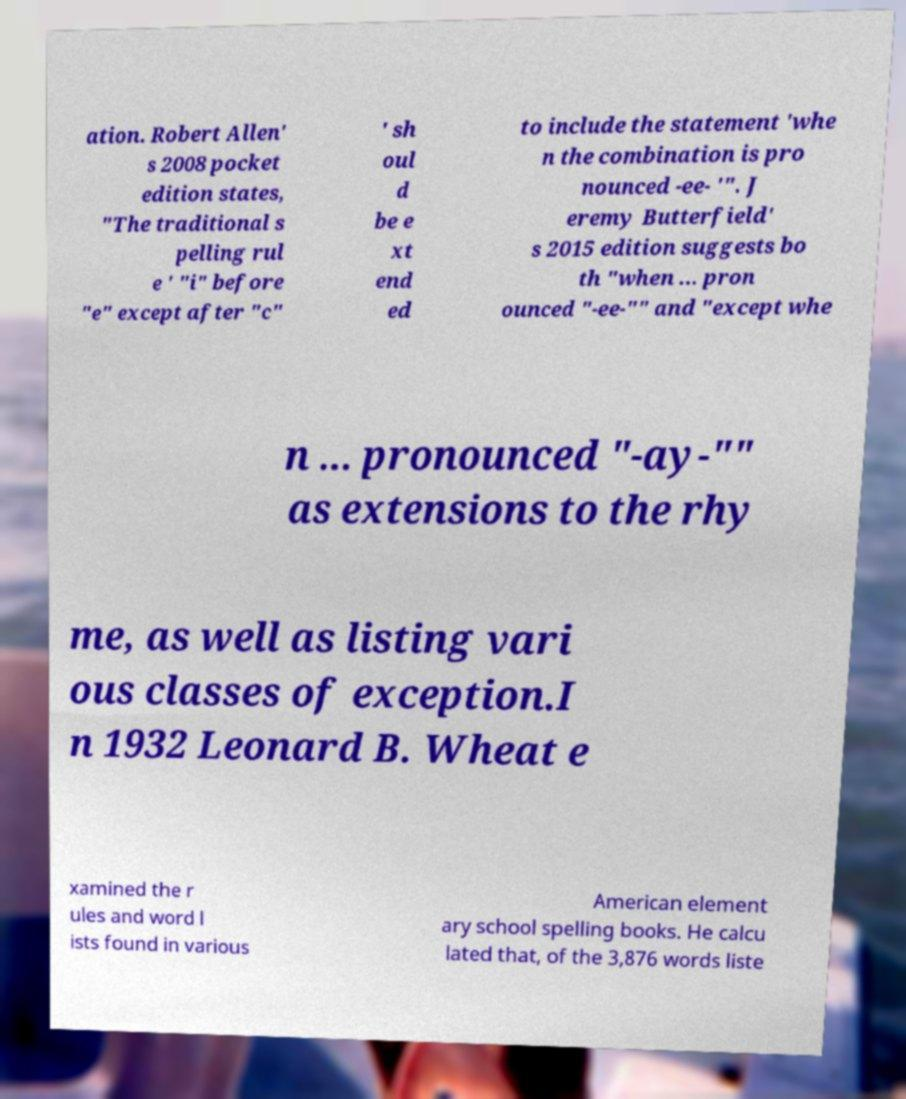There's text embedded in this image that I need extracted. Can you transcribe it verbatim? ation. Robert Allen' s 2008 pocket edition states, "The traditional s pelling rul e ' "i" before "e" except after "c" ' sh oul d be e xt end ed to include the statement 'whe n the combination is pro nounced -ee- '". J eremy Butterfield' s 2015 edition suggests bo th "when ... pron ounced "-ee-"" and "except whe n ... pronounced "-ay-"" as extensions to the rhy me, as well as listing vari ous classes of exception.I n 1932 Leonard B. Wheat e xamined the r ules and word l ists found in various American element ary school spelling books. He calcu lated that, of the 3,876 words liste 